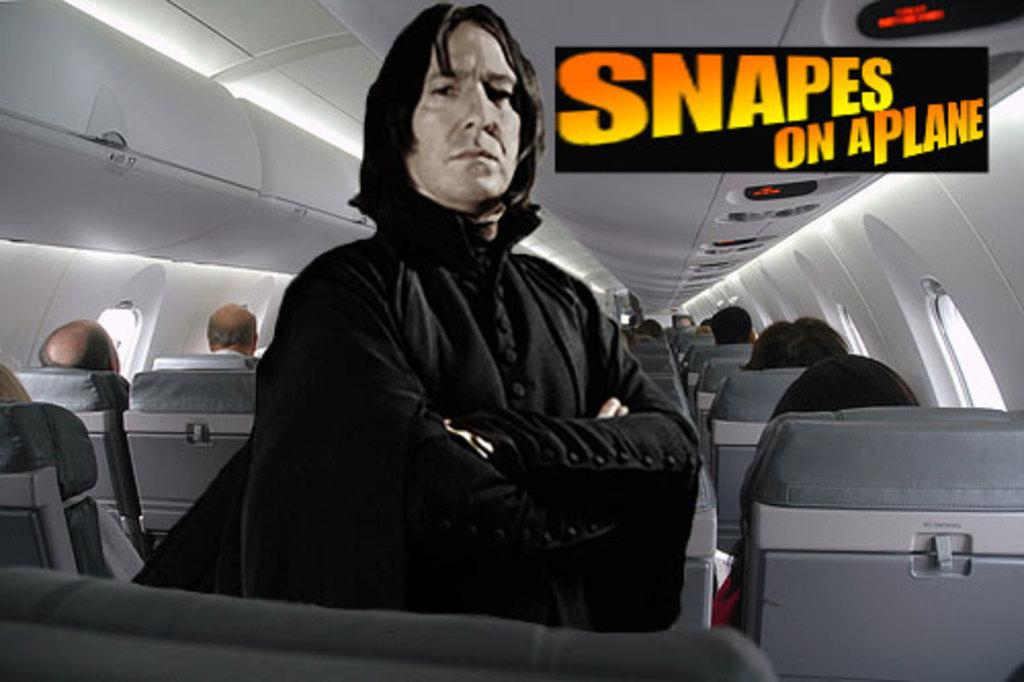What are the people in the image doing? The people in the image are sitting on chairs. What can be seen beside the people sitting on chairs? There are windows beside the people. What is the position of the man in the image? There is a man standing in front of the people. What type of iron can be seen on the shelf behind the people? There is no iron or shelf present in the image. What discovery was made by the people sitting on chairs? There is no indication in the image of any discovery being made by the people sitting on chairs. 